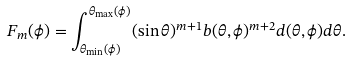<formula> <loc_0><loc_0><loc_500><loc_500>F _ { m } ( \phi ) = \int _ { \theta _ { \min } ( \phi ) } ^ { \theta _ { \max } ( \phi ) } ( \sin { \theta } ) ^ { m + 1 } b ( \theta , \phi ) ^ { m + 2 } d ( \theta , \phi ) d \theta .</formula> 